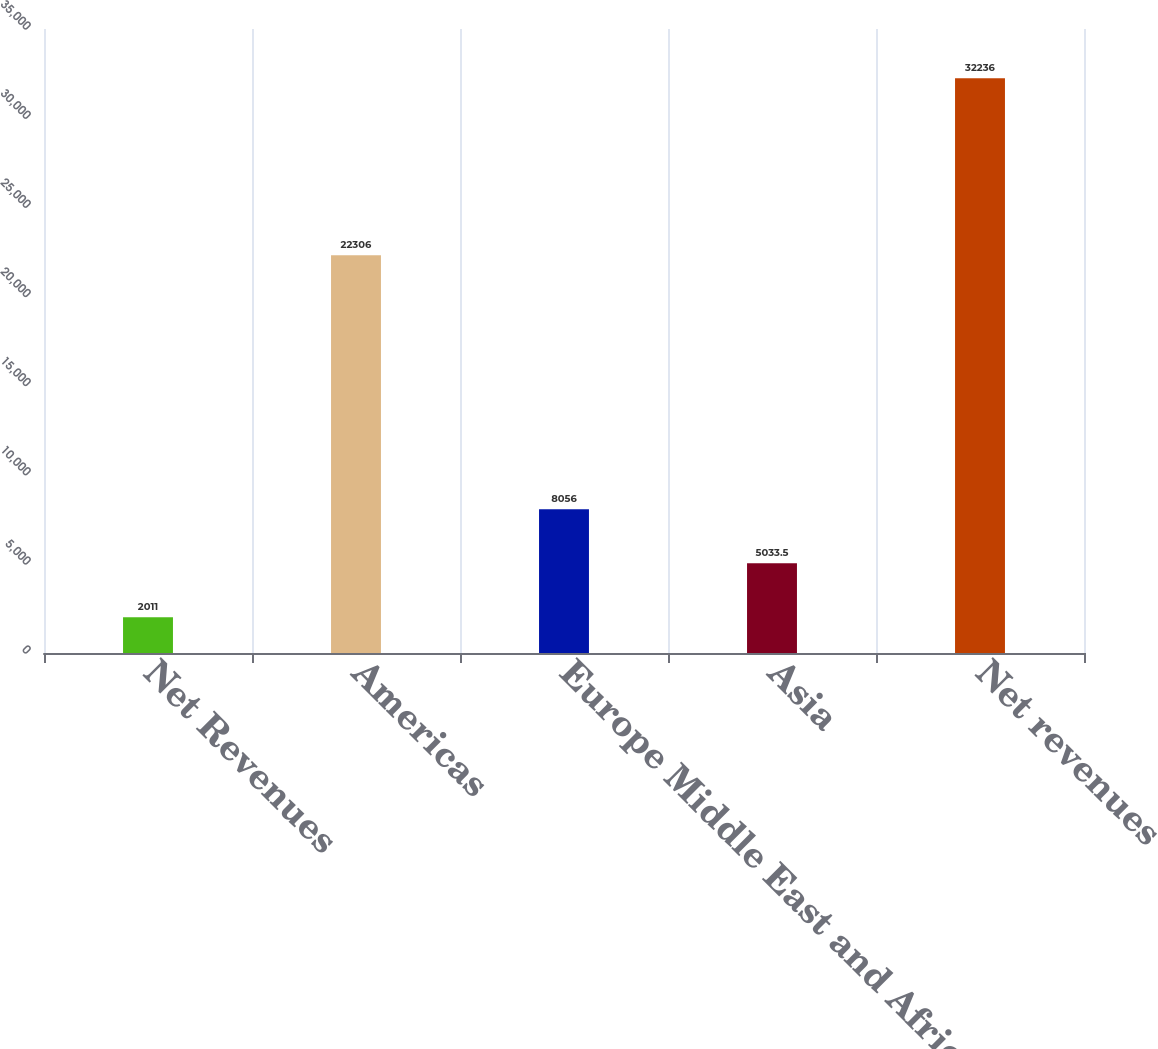Convert chart to OTSL. <chart><loc_0><loc_0><loc_500><loc_500><bar_chart><fcel>Net Revenues<fcel>Americas<fcel>Europe Middle East and Africa<fcel>Asia<fcel>Net revenues<nl><fcel>2011<fcel>22306<fcel>8056<fcel>5033.5<fcel>32236<nl></chart> 